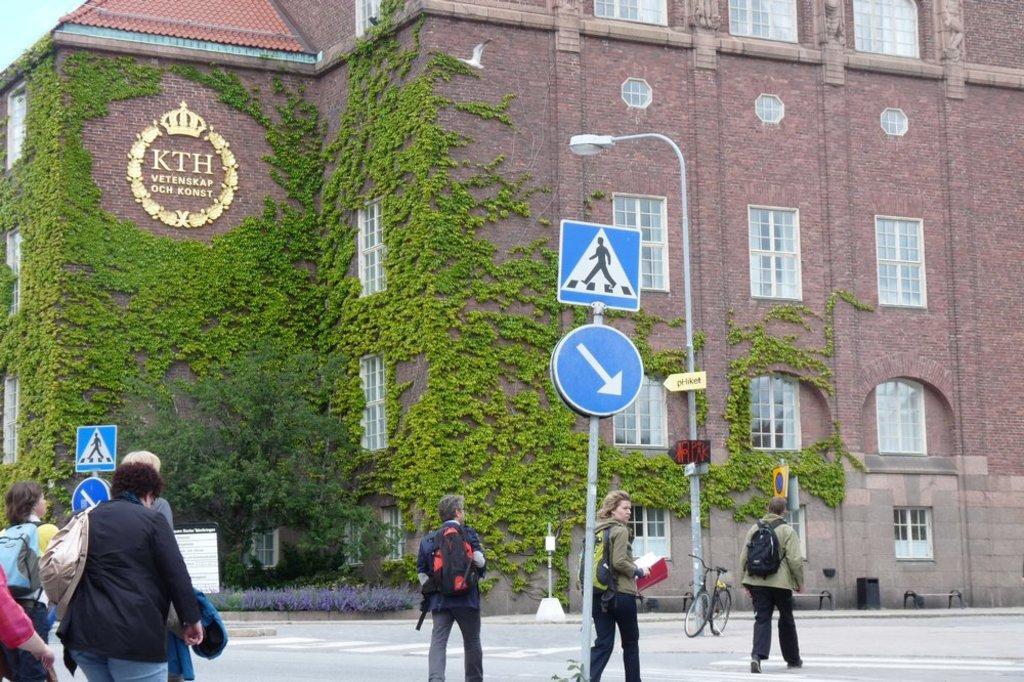In one or two sentences, can you explain what this image depicts? On the left side 2 persons are walking on the road, in the middle it is a sign board and this is the building, there are green plants on it. 